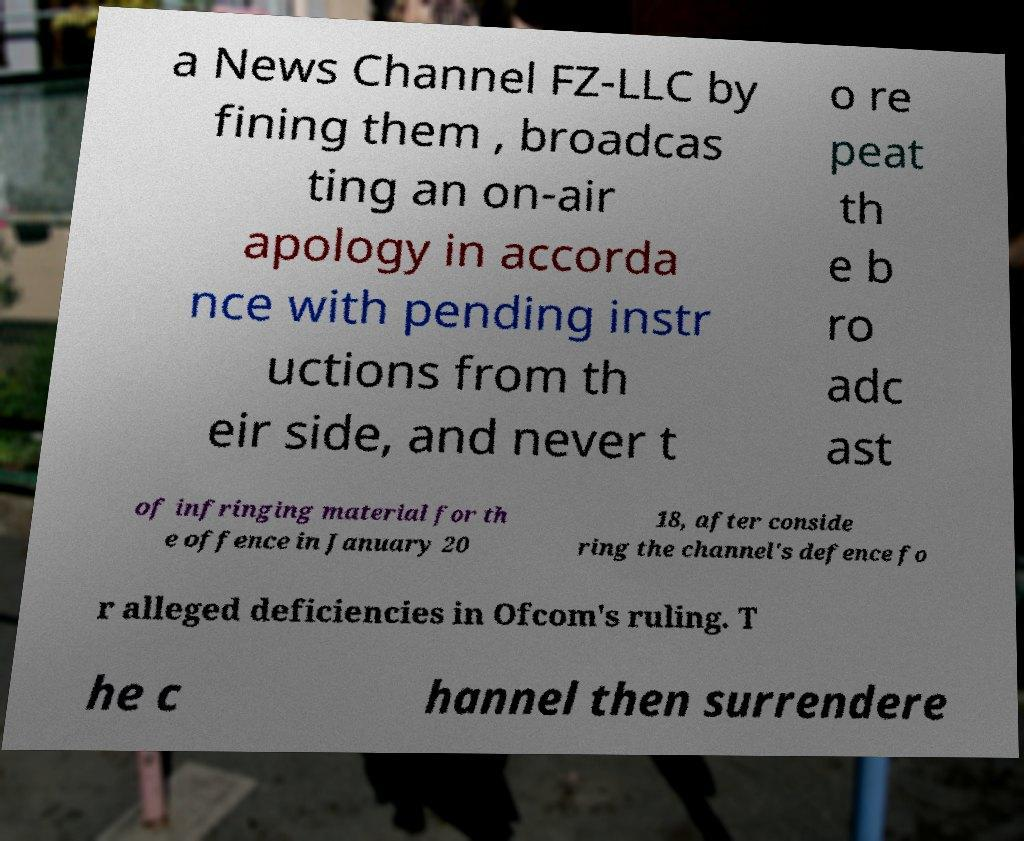There's text embedded in this image that I need extracted. Can you transcribe it verbatim? a News Channel FZ-LLC by fining them , broadcas ting an on-air apology in accorda nce with pending instr uctions from th eir side, and never t o re peat th e b ro adc ast of infringing material for th e offence in January 20 18, after conside ring the channel's defence fo r alleged deficiencies in Ofcom's ruling. T he c hannel then surrendere 